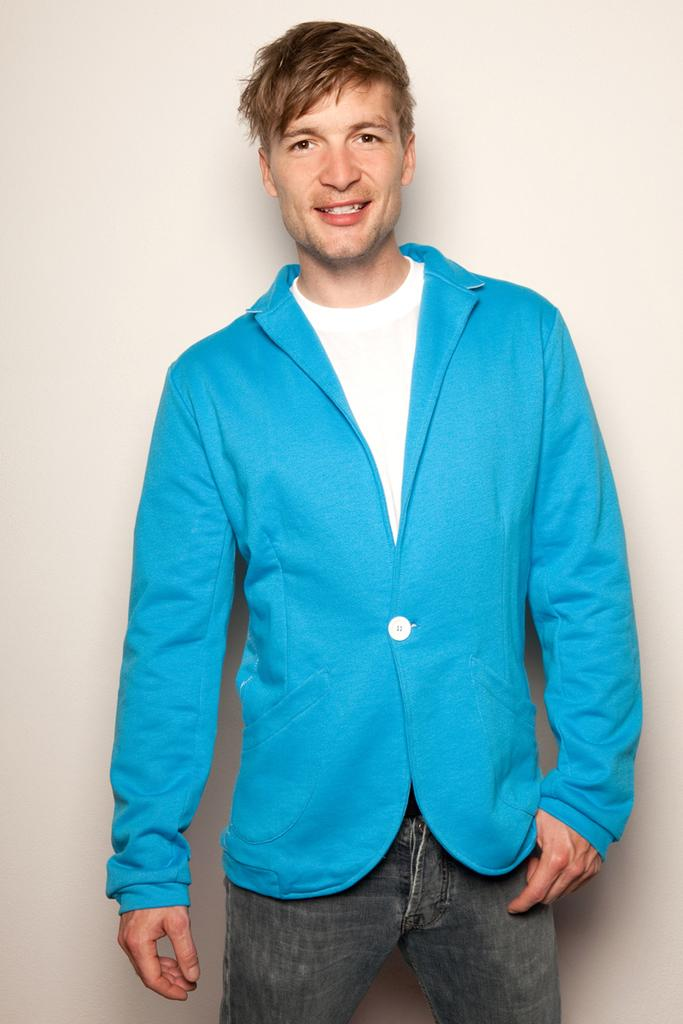Who is present in the image? There is a man in the image. What is the man wearing? The man is wearing a blue jacket. What is the man doing in the image? The man is standing and smiling. What can be seen in the background of the image? There is a wall visible in the background of the image. How many trees can be seen in the image? There are no trees visible in the image; it only features a man and a wall in the background. 